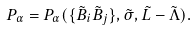Convert formula to latex. <formula><loc_0><loc_0><loc_500><loc_500>P _ { \alpha } = P _ { \alpha } ( \{ \tilde { B } _ { i } \tilde { B } _ { j } \} , \tilde { \sigma } , \tilde { L } - \tilde { \Lambda } ) .</formula> 